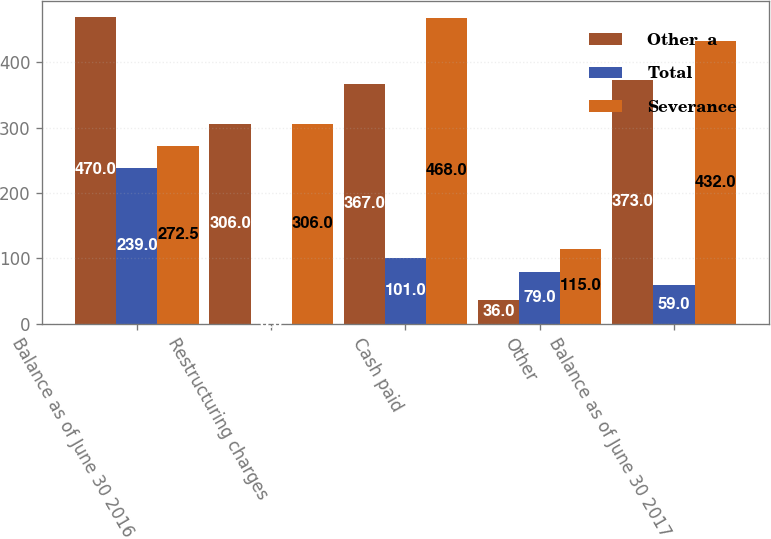Convert chart to OTSL. <chart><loc_0><loc_0><loc_500><loc_500><stacked_bar_chart><ecel><fcel>Balance as of June 30 2016<fcel>Restructuring charges<fcel>Cash paid<fcel>Other<fcel>Balance as of June 30 2017<nl><fcel>Other  a<fcel>470<fcel>306<fcel>367<fcel>36<fcel>373<nl><fcel>Total<fcel>239<fcel>0<fcel>101<fcel>79<fcel>59<nl><fcel>Severance<fcel>272.5<fcel>306<fcel>468<fcel>115<fcel>432<nl></chart> 